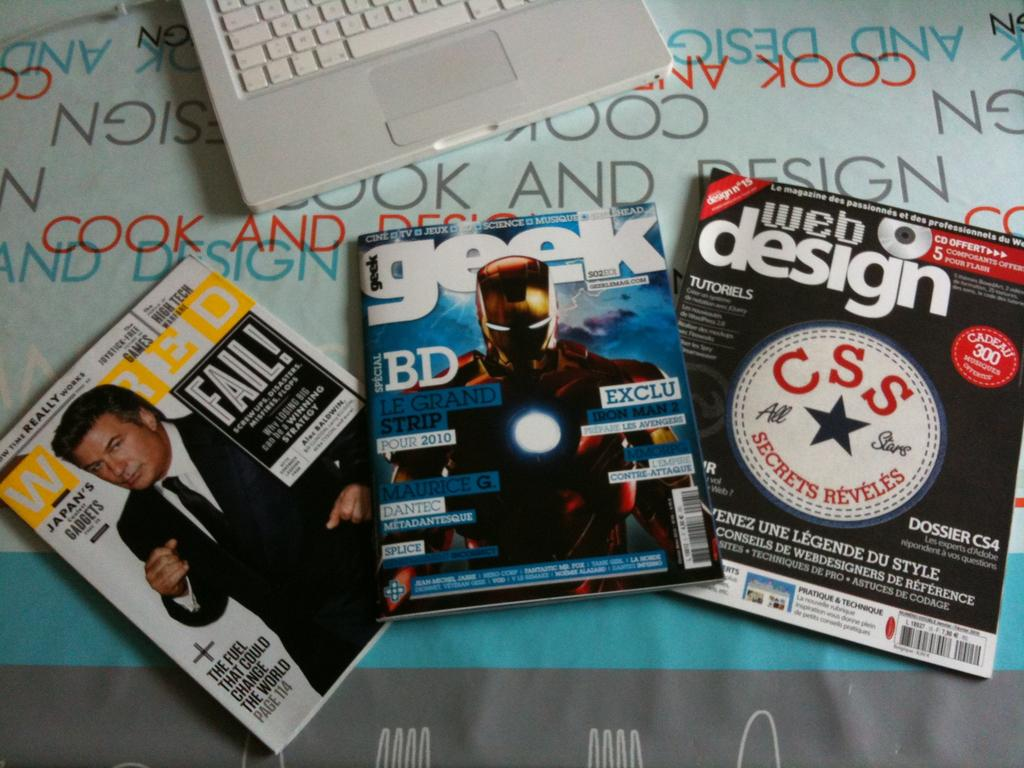<image>
Provide a brief description of the given image. Three magazines spread out on a table and one is a Geek magazine. 